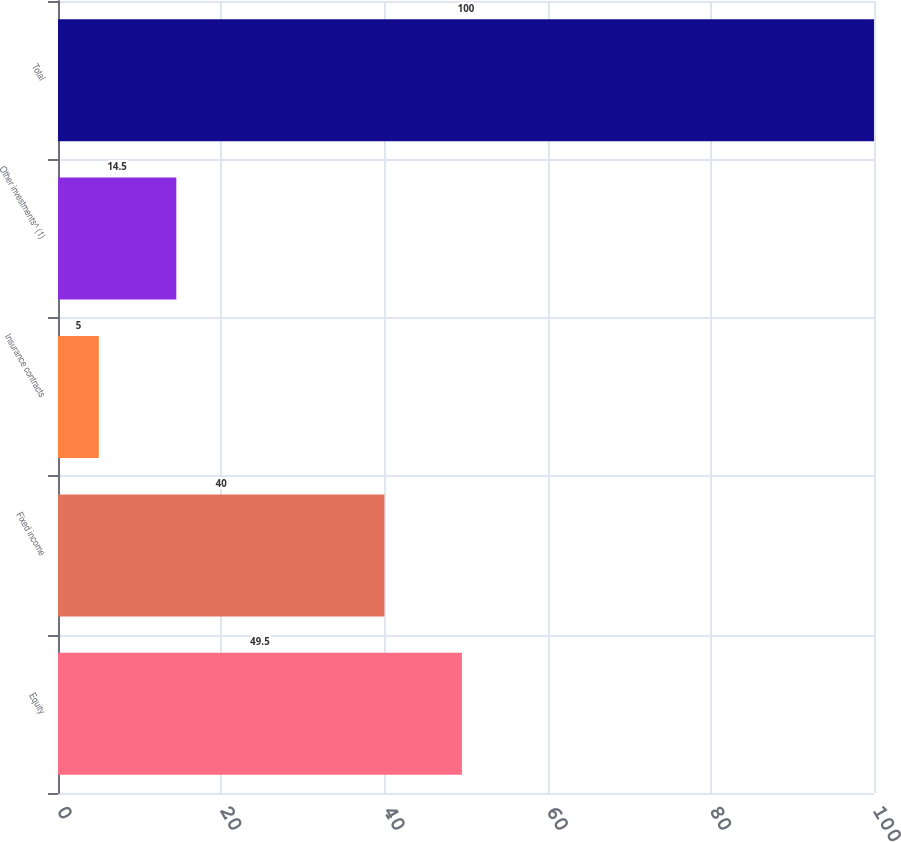Convert chart to OTSL. <chart><loc_0><loc_0><loc_500><loc_500><bar_chart><fcel>Equity<fcel>Fixed income<fcel>Insurance contracts<fcel>Other investments^ (1)<fcel>Total<nl><fcel>49.5<fcel>40<fcel>5<fcel>14.5<fcel>100<nl></chart> 